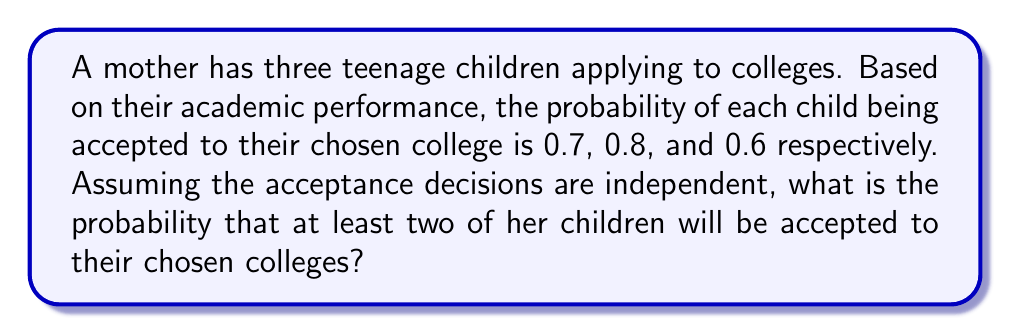Provide a solution to this math problem. Let's approach this step-by-step:

1) First, we need to calculate the probability of the complement event: the probability that fewer than two children are accepted. This includes the cases where either no child is accepted or only one child is accepted.

2) Let's define events:
   A: first child is accepted (P(A) = 0.7)
   B: second child is accepted (P(B) = 0.8)
   C: third child is accepted (P(C) = 0.6)

3) Probability of no child being accepted:
   $P(\text{none}) = (1-0.7)(1-0.8)(1-0.6) = 0.3 \times 0.2 \times 0.4 = 0.024$

4) Probability of exactly one child being accepted:
   $P(\text{only A}) = 0.7 \times 0.2 \times 0.4 = 0.056$
   $P(\text{only B}) = 0.3 \times 0.8 \times 0.4 = 0.096$
   $P(\text{only C}) = 0.3 \times 0.2 \times 0.6 = 0.036$
   
   $P(\text{one}) = 0.056 + 0.096 + 0.036 = 0.188$

5) Probability of fewer than two children being accepted:
   $P(\text{fewer than two}) = P(\text{none}) + P(\text{one}) = 0.024 + 0.188 = 0.212$

6) Therefore, the probability of at least two children being accepted is:
   $P(\text{at least two}) = 1 - P(\text{fewer than two}) = 1 - 0.212 = 0.788$
Answer: 0.788 